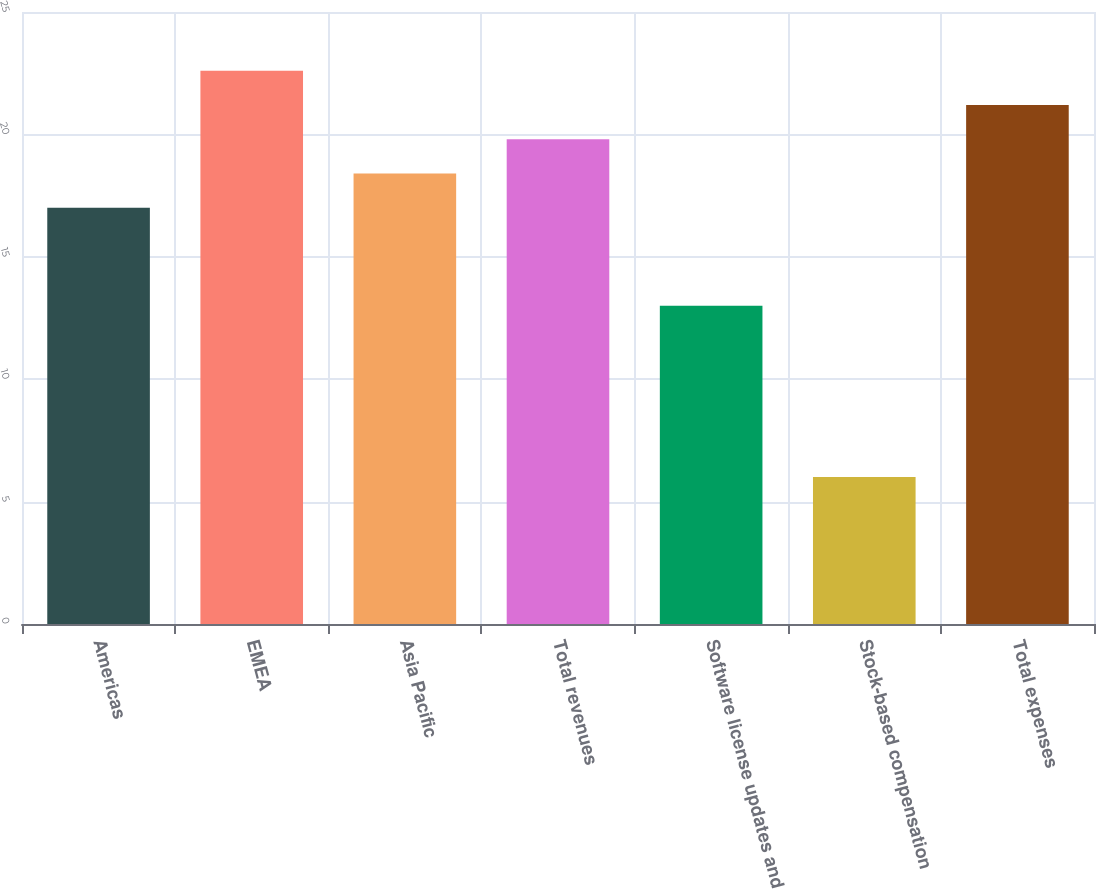<chart> <loc_0><loc_0><loc_500><loc_500><bar_chart><fcel>Americas<fcel>EMEA<fcel>Asia Pacific<fcel>Total revenues<fcel>Software license updates and<fcel>Stock-based compensation<fcel>Total expenses<nl><fcel>17<fcel>22.6<fcel>18.4<fcel>19.8<fcel>13<fcel>6<fcel>21.2<nl></chart> 